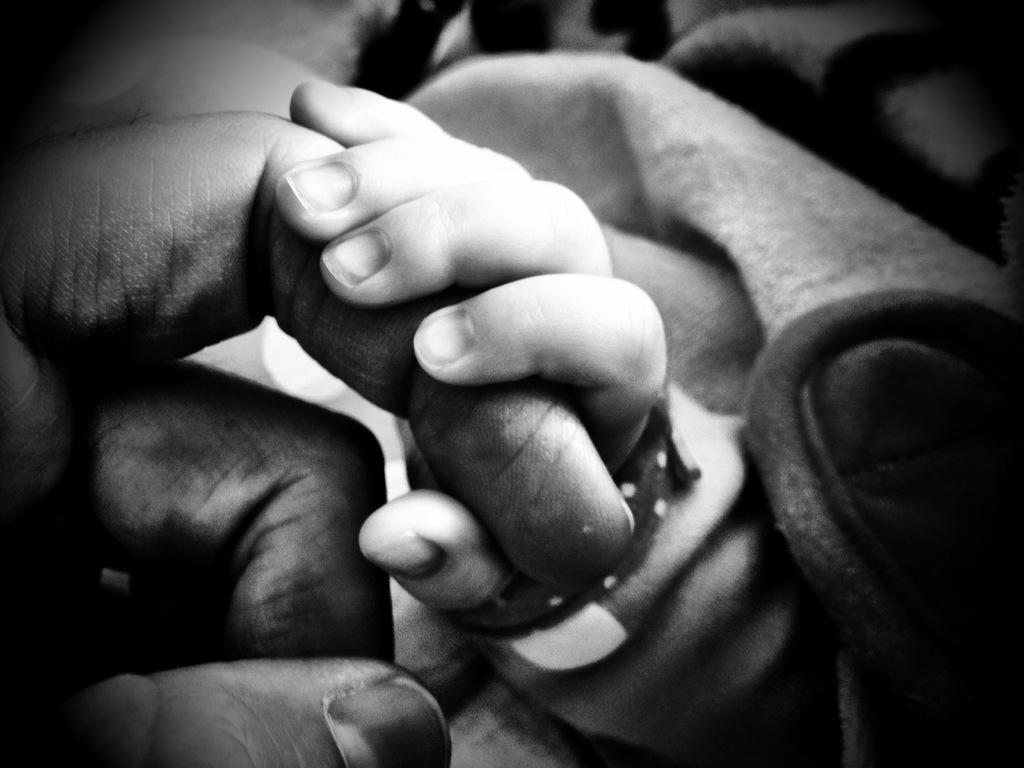What body parts are visible in the image? There is a person's hand and a baby's hand in the image. How are the hands interacting with each other? The baby's hand is holding a finger of the person's hand. What type of kittens can be seen playing with a copper pump in the image? There are no kittens or pumps present in the image; it only features a person's hand and a baby's hand interacting. 